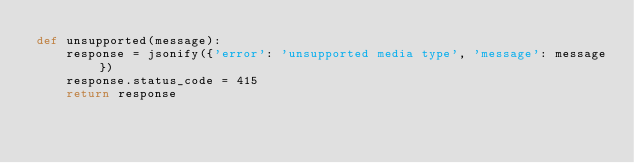Convert code to text. <code><loc_0><loc_0><loc_500><loc_500><_Python_>def unsupported(message):
    response = jsonify({'error': 'unsupported media type', 'message': message})
    response.status_code = 415
    return response
</code> 